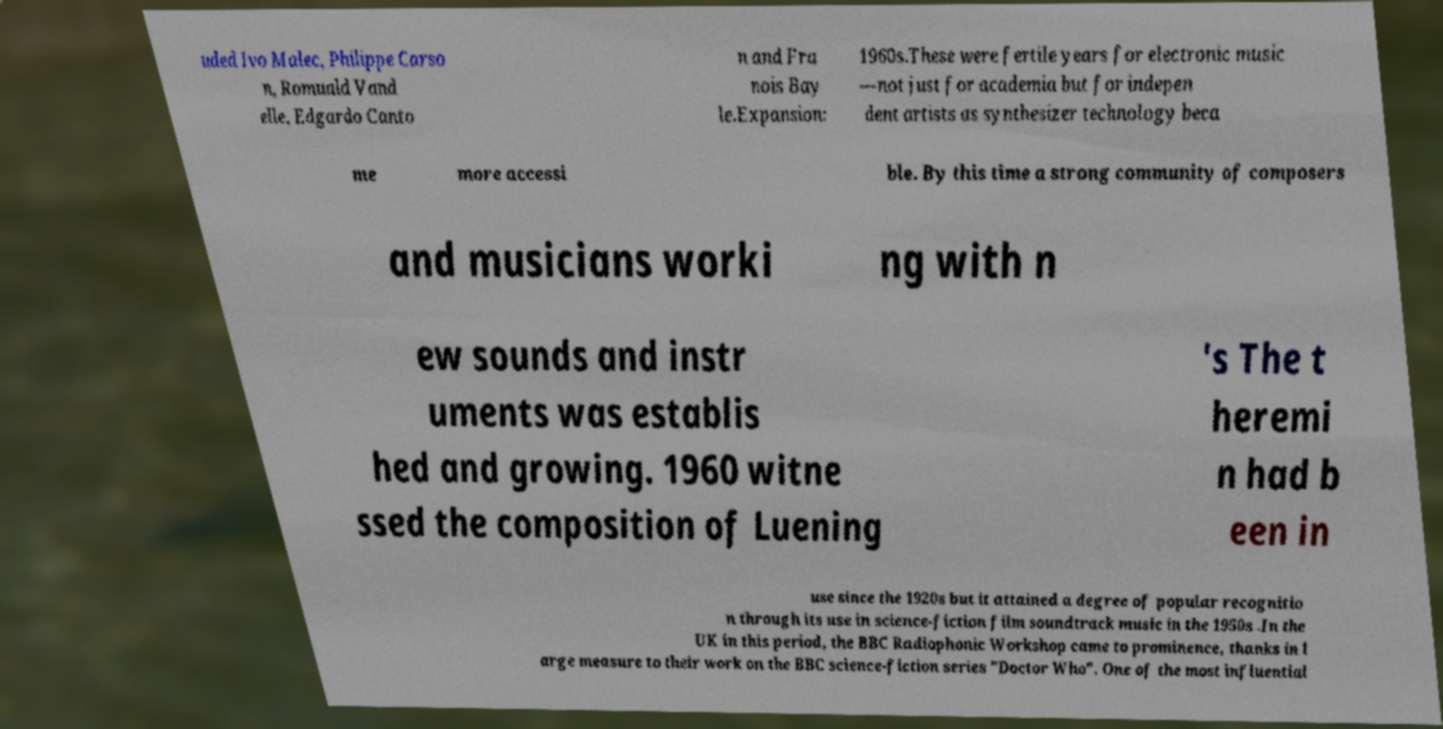What messages or text are displayed in this image? I need them in a readable, typed format. uded Ivo Malec, Philippe Carso n, Romuald Vand elle, Edgardo Canto n and Fra nois Bay le.Expansion: 1960s.These were fertile years for electronic music —not just for academia but for indepen dent artists as synthesizer technology beca me more accessi ble. By this time a strong community of composers and musicians worki ng with n ew sounds and instr uments was establis hed and growing. 1960 witne ssed the composition of Luening 's The t heremi n had b een in use since the 1920s but it attained a degree of popular recognitio n through its use in science-fiction film soundtrack music in the 1950s .In the UK in this period, the BBC Radiophonic Workshop came to prominence, thanks in l arge measure to their work on the BBC science-fiction series "Doctor Who". One of the most influential 